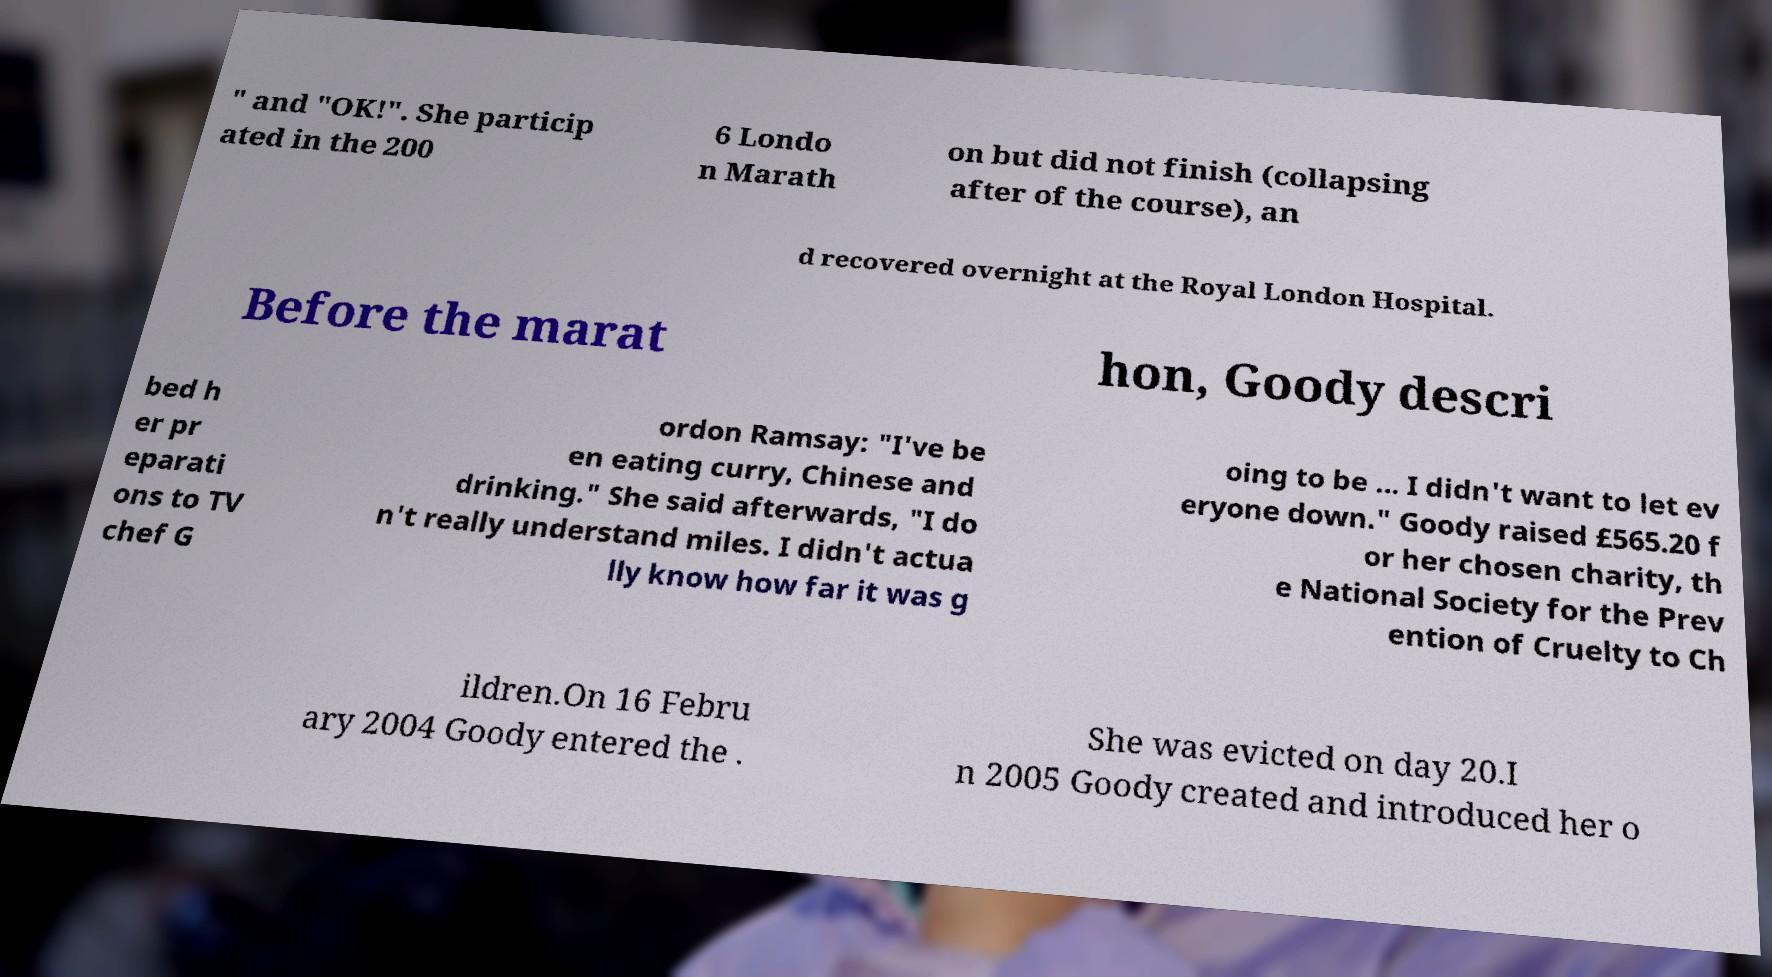Can you accurately transcribe the text from the provided image for me? " and "OK!". She particip ated in the 200 6 Londo n Marath on but did not finish (collapsing after of the course), an d recovered overnight at the Royal London Hospital. Before the marat hon, Goody descri bed h er pr eparati ons to TV chef G ordon Ramsay: "I've be en eating curry, Chinese and drinking." She said afterwards, "I do n't really understand miles. I didn't actua lly know how far it was g oing to be ... I didn't want to let ev eryone down." Goody raised £565.20 f or her chosen charity, th e National Society for the Prev ention of Cruelty to Ch ildren.On 16 Febru ary 2004 Goody entered the . She was evicted on day 20.I n 2005 Goody created and introduced her o 